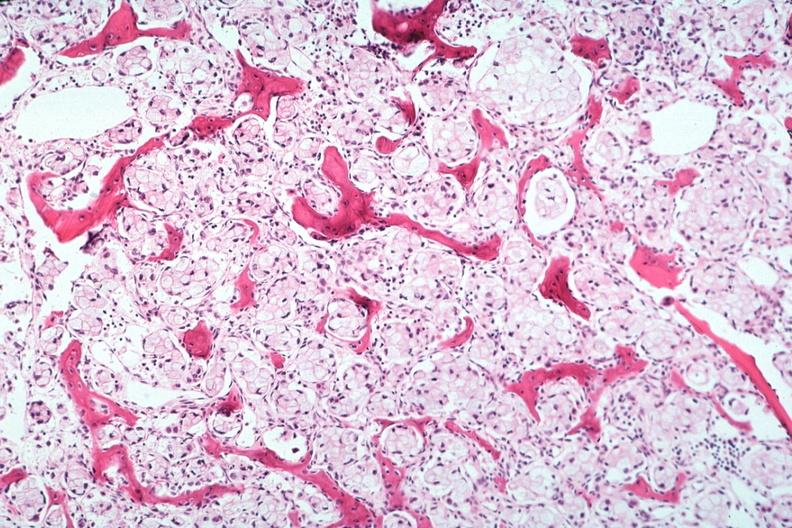s joints present?
Answer the question using a single word or phrase. Yes 